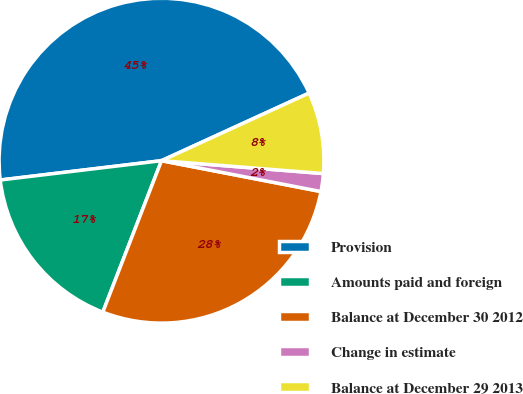Convert chart. <chart><loc_0><loc_0><loc_500><loc_500><pie_chart><fcel>Provision<fcel>Amounts paid and foreign<fcel>Balance at December 30 2012<fcel>Change in estimate<fcel>Balance at December 29 2013<nl><fcel>45.06%<fcel>17.22%<fcel>27.84%<fcel>1.78%<fcel>8.1%<nl></chart> 